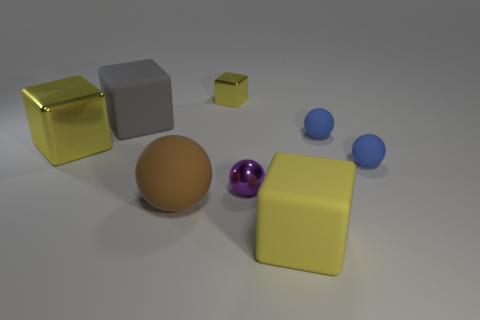Subtract all rubber balls. How many balls are left? 1 Subtract all yellow spheres. How many yellow cubes are left? 3 Subtract all purple spheres. How many spheres are left? 3 Add 1 yellow metallic cubes. How many objects exist? 9 Subtract all green spheres. Subtract all green cylinders. How many spheres are left? 4 Subtract all brown rubber objects. Subtract all big brown matte spheres. How many objects are left? 6 Add 2 large cubes. How many large cubes are left? 5 Add 6 small purple metal objects. How many small purple metal objects exist? 7 Subtract 0 brown cubes. How many objects are left? 8 